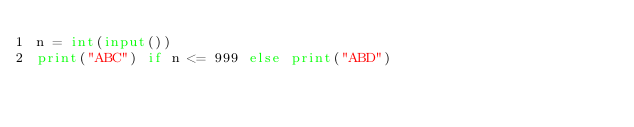Convert code to text. <code><loc_0><loc_0><loc_500><loc_500><_Python_>n = int(input())
print("ABC") if n <= 999 else print("ABD")</code> 